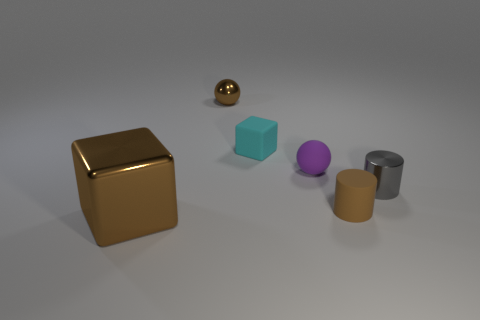Add 2 cyan rubber cubes. How many objects exist? 8 Subtract all cylinders. How many objects are left? 4 Subtract all cylinders. Subtract all blocks. How many objects are left? 2 Add 6 brown rubber objects. How many brown rubber objects are left? 7 Add 1 small cyan matte balls. How many small cyan matte balls exist? 1 Subtract 1 gray cylinders. How many objects are left? 5 